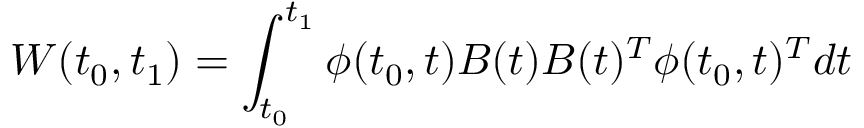Convert formula to latex. <formula><loc_0><loc_0><loc_500><loc_500>W ( t _ { 0 } , t _ { 1 } ) = \int _ { t _ { 0 } } ^ { t _ { 1 } } \phi ( t _ { 0 } , t ) B ( t ) B ( t ) ^ { T } \phi ( t _ { 0 } , t ) ^ { T } d t</formula> 